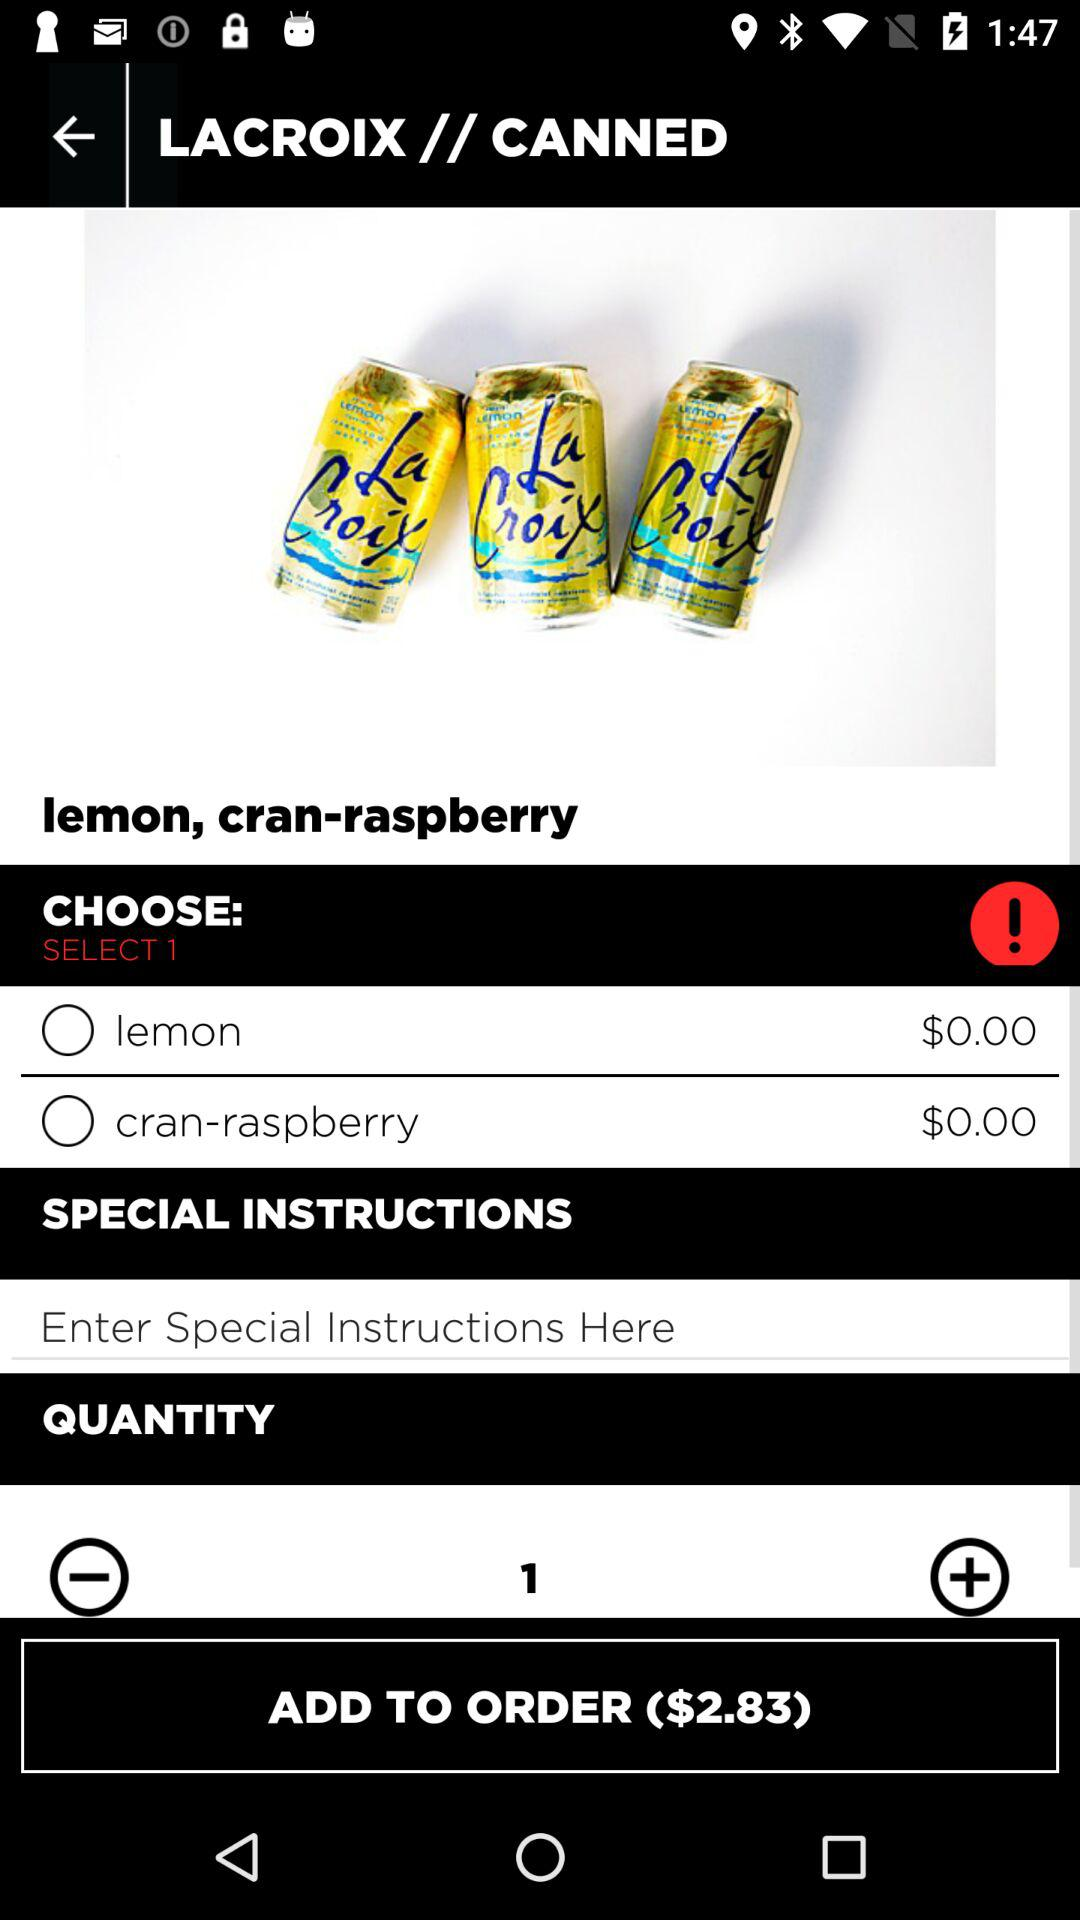What are the special instructions that are entered into the text field?
When the provided information is insufficient, respond with <no answer>. <no answer> 